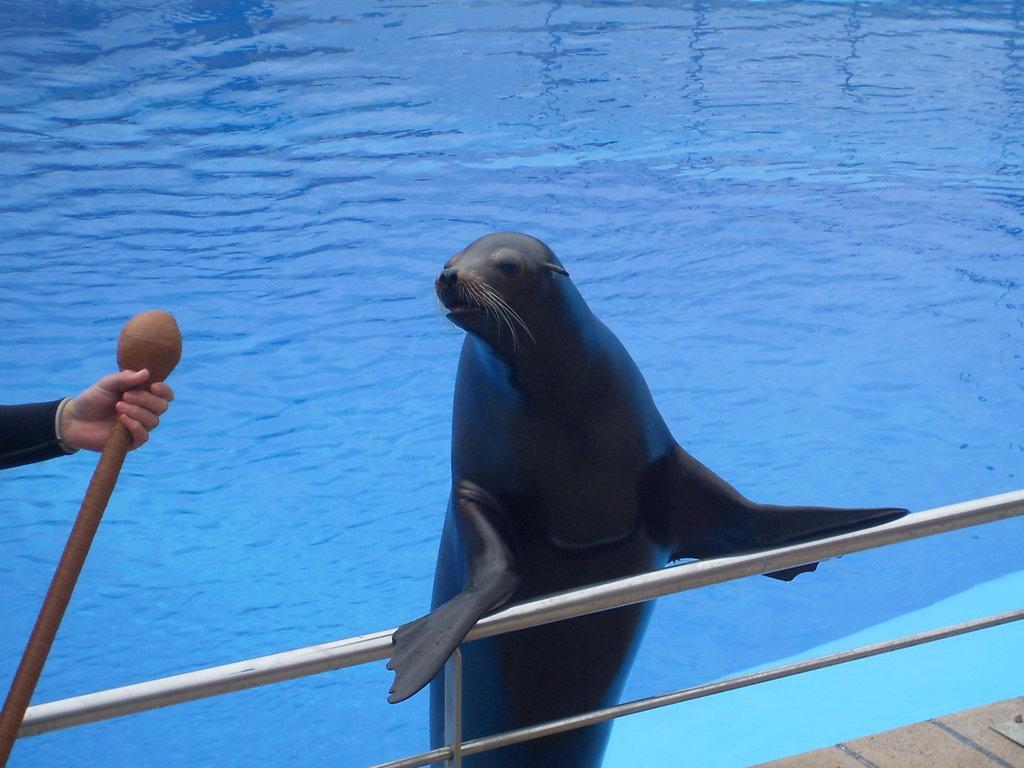In one or two sentences, can you explain what this image depicts? In the picture we can see water in the pool which is blue in color and near it, we can see railing on it, we can see a sea lion sitting near it holds a railing and beside it we can see a person's hand holding a stick. 